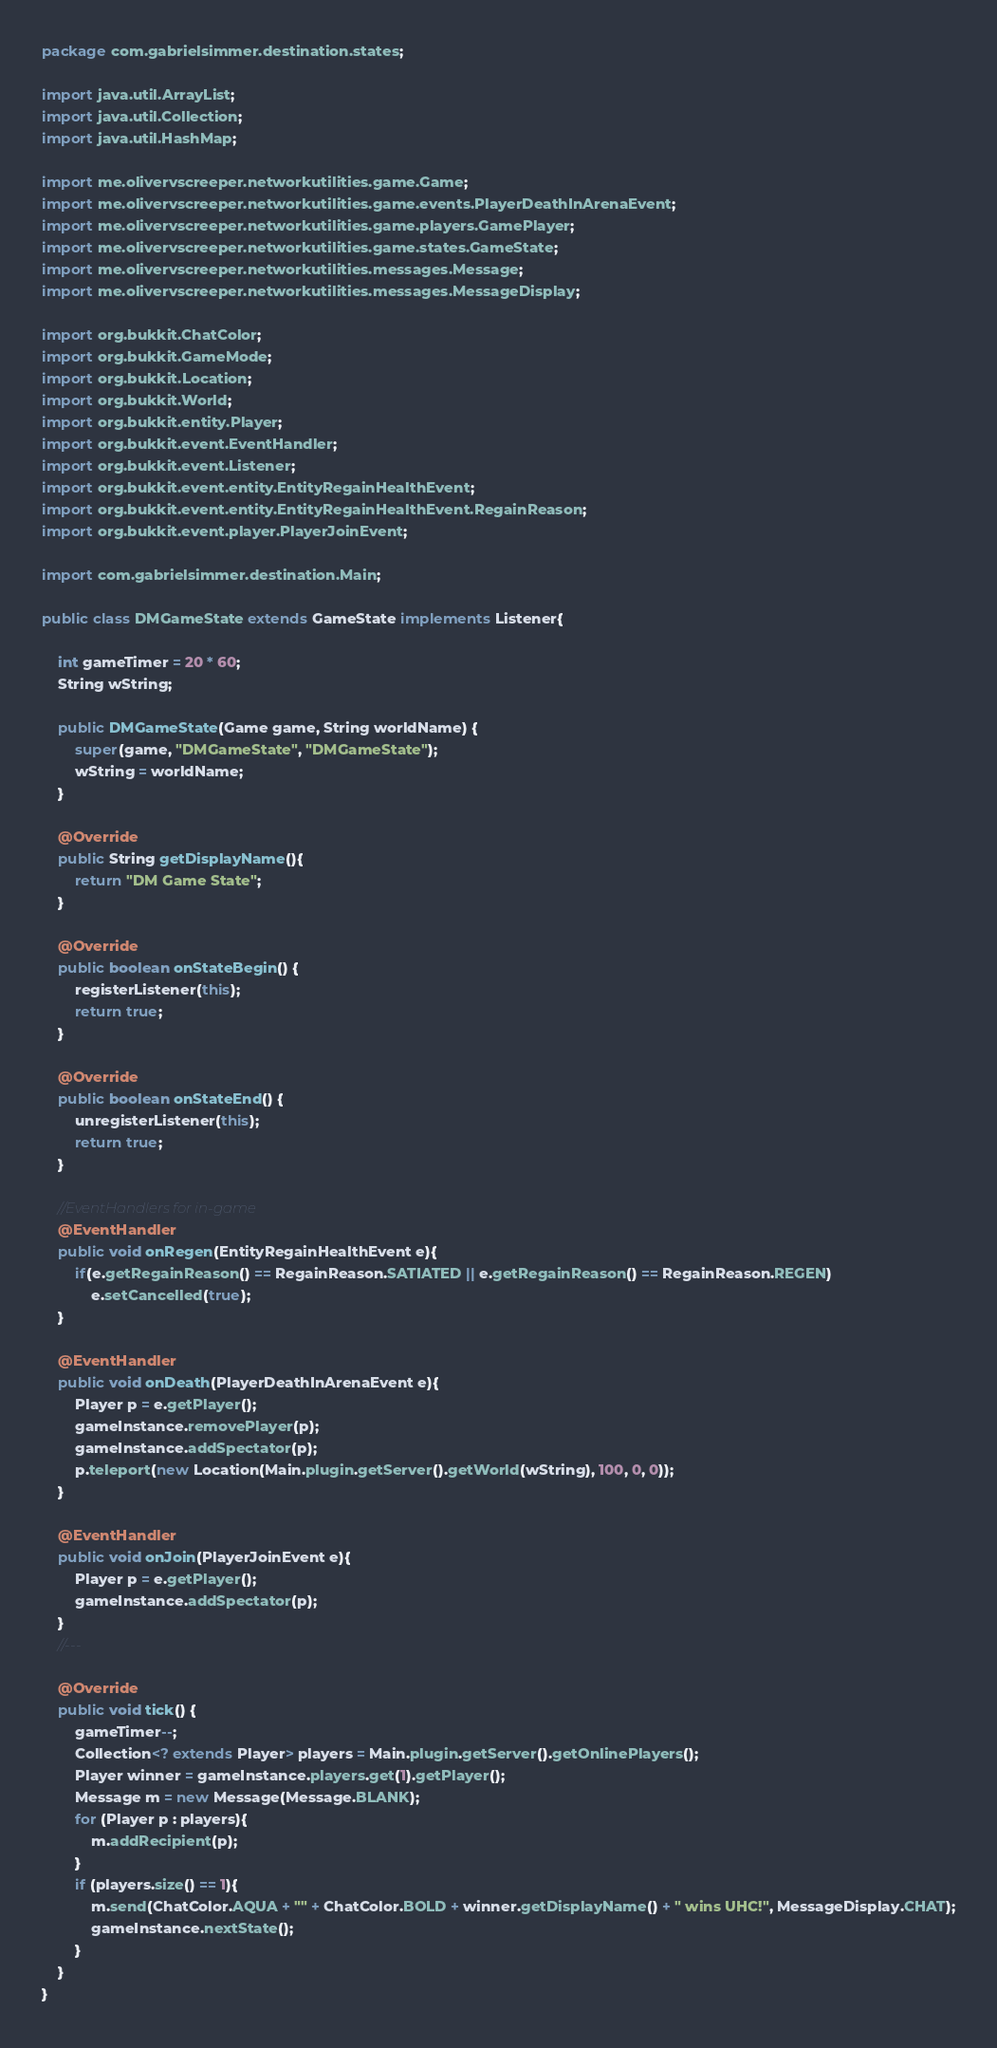Convert code to text. <code><loc_0><loc_0><loc_500><loc_500><_Java_>package com.gabrielsimmer.destination.states;

import java.util.ArrayList;
import java.util.Collection;
import java.util.HashMap;

import me.olivervscreeper.networkutilities.game.Game;
import me.olivervscreeper.networkutilities.game.events.PlayerDeathInArenaEvent;
import me.olivervscreeper.networkutilities.game.players.GamePlayer;
import me.olivervscreeper.networkutilities.game.states.GameState;
import me.olivervscreeper.networkutilities.messages.Message;
import me.olivervscreeper.networkutilities.messages.MessageDisplay;

import org.bukkit.ChatColor;
import org.bukkit.GameMode;
import org.bukkit.Location;
import org.bukkit.World;
import org.bukkit.entity.Player;
import org.bukkit.event.EventHandler;
import org.bukkit.event.Listener;
import org.bukkit.event.entity.EntityRegainHealthEvent;
import org.bukkit.event.entity.EntityRegainHealthEvent.RegainReason;
import org.bukkit.event.player.PlayerJoinEvent;

import com.gabrielsimmer.destination.Main;

public class DMGameState extends GameState implements Listener{

	int gameTimer = 20 * 60;
	String wString;

	public DMGameState(Game game, String worldName) {
		super(game, "DMGameState", "DMGameState");
		wString = worldName;
	}

	@Override
	public String getDisplayName(){
		return "DM Game State";
	}

	@Override
	public boolean onStateBegin() {
		registerListener(this);
		return true;
	}

	@Override
	public boolean onStateEnd() {
		unregisterListener(this);
		return true;
	}

	//EventHandlers for in-game
	@EventHandler
	public void onRegen(EntityRegainHealthEvent e){
		if(e.getRegainReason() == RegainReason.SATIATED || e.getRegainReason() == RegainReason.REGEN)
			e.setCancelled(true);
	}

	@EventHandler
	public void onDeath(PlayerDeathInArenaEvent e){
		Player p = e.getPlayer();
		gameInstance.removePlayer(p);
		gameInstance.addSpectator(p);
		p.teleport(new Location(Main.plugin.getServer().getWorld(wString), 100, 0, 0));
	}

	@EventHandler
	public void onJoin(PlayerJoinEvent e){
		Player p = e.getPlayer();
		gameInstance.addSpectator(p);
	}
	//---

	@Override
	public void tick() {
		gameTimer--;
		Collection<? extends Player> players = Main.plugin.getServer().getOnlinePlayers();
		Player winner = gameInstance.players.get(1).getPlayer();
		Message m = new Message(Message.BLANK);
		for (Player p : players){
			m.addRecipient(p);
		}
		if (players.size() == 1){
			m.send(ChatColor.AQUA + "" + ChatColor.BOLD + winner.getDisplayName() + " wins UHC!", MessageDisplay.CHAT);
			gameInstance.nextState();
		}
	}
}
</code> 